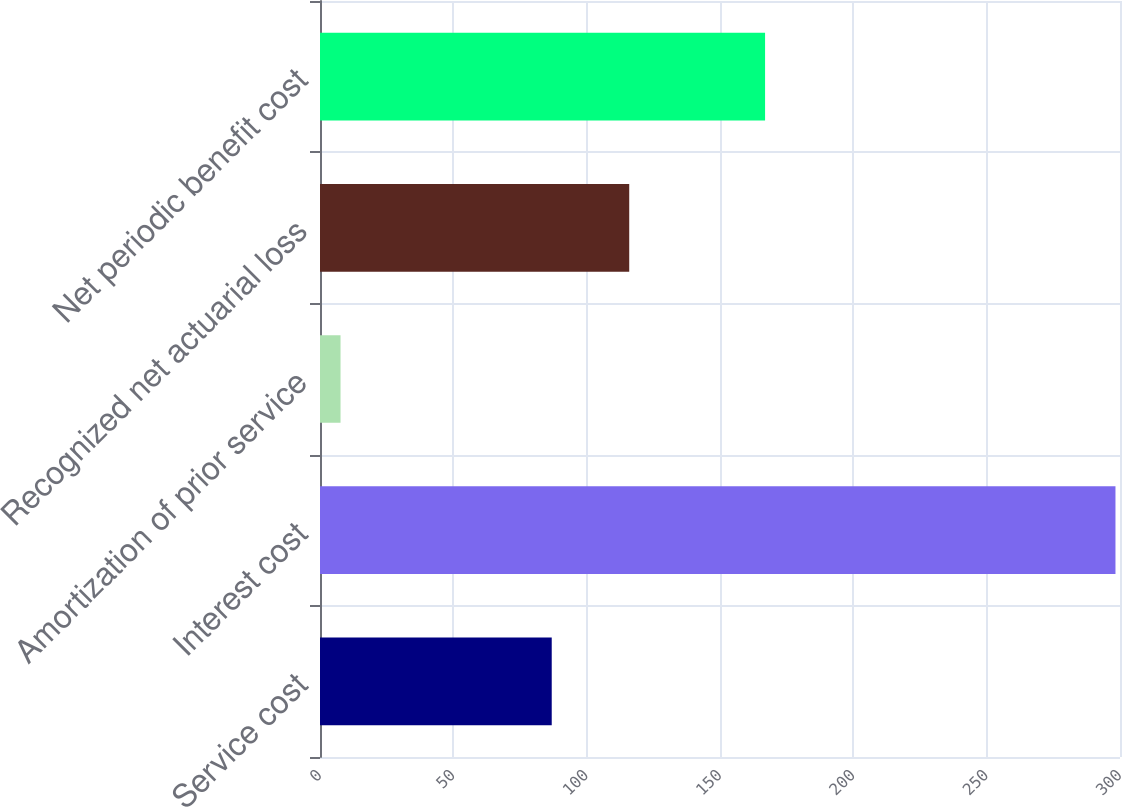Convert chart to OTSL. <chart><loc_0><loc_0><loc_500><loc_500><bar_chart><fcel>Service cost<fcel>Interest cost<fcel>Amortization of prior service<fcel>Recognized net actuarial loss<fcel>Net periodic benefit cost<nl><fcel>86.9<fcel>298.3<fcel>7.7<fcel>115.96<fcel>166.9<nl></chart> 